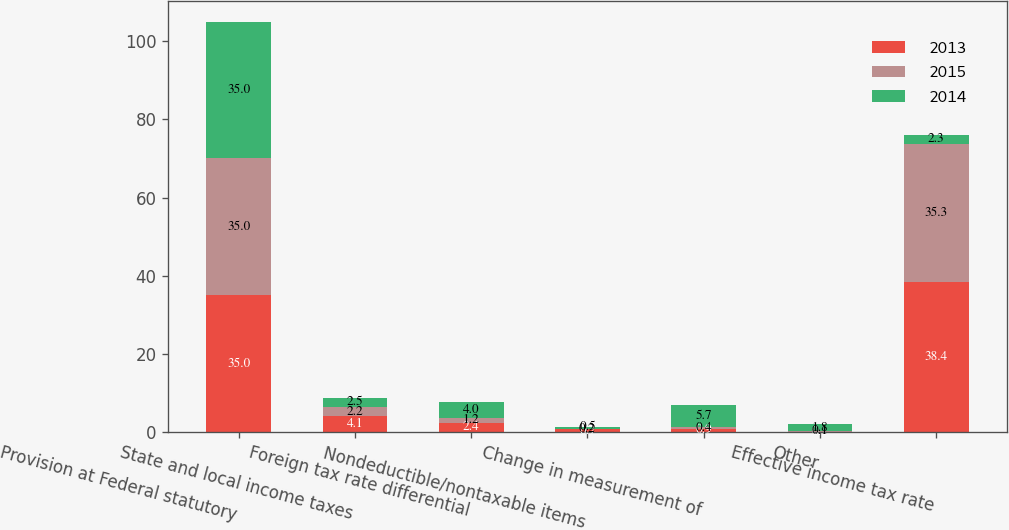<chart> <loc_0><loc_0><loc_500><loc_500><stacked_bar_chart><ecel><fcel>Provision at Federal statutory<fcel>State and local income taxes<fcel>Foreign tax rate differential<fcel>Nondeductible/nontaxable items<fcel>Change in measurement of<fcel>Other<fcel>Effective income tax rate<nl><fcel>2013<fcel>35<fcel>4.1<fcel>2.4<fcel>0.7<fcel>0.9<fcel>0.1<fcel>38.4<nl><fcel>2015<fcel>35<fcel>2.2<fcel>1.2<fcel>0.2<fcel>0.4<fcel>0.1<fcel>35.3<nl><fcel>2014<fcel>35<fcel>2.5<fcel>4<fcel>0.5<fcel>5.7<fcel>1.8<fcel>2.3<nl></chart> 